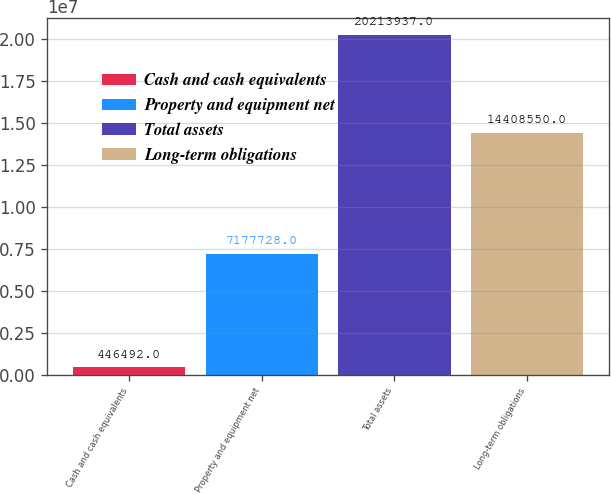<chart> <loc_0><loc_0><loc_500><loc_500><bar_chart><fcel>Cash and cash equivalents<fcel>Property and equipment net<fcel>Total assets<fcel>Long-term obligations<nl><fcel>446492<fcel>7.17773e+06<fcel>2.02139e+07<fcel>1.44086e+07<nl></chart> 